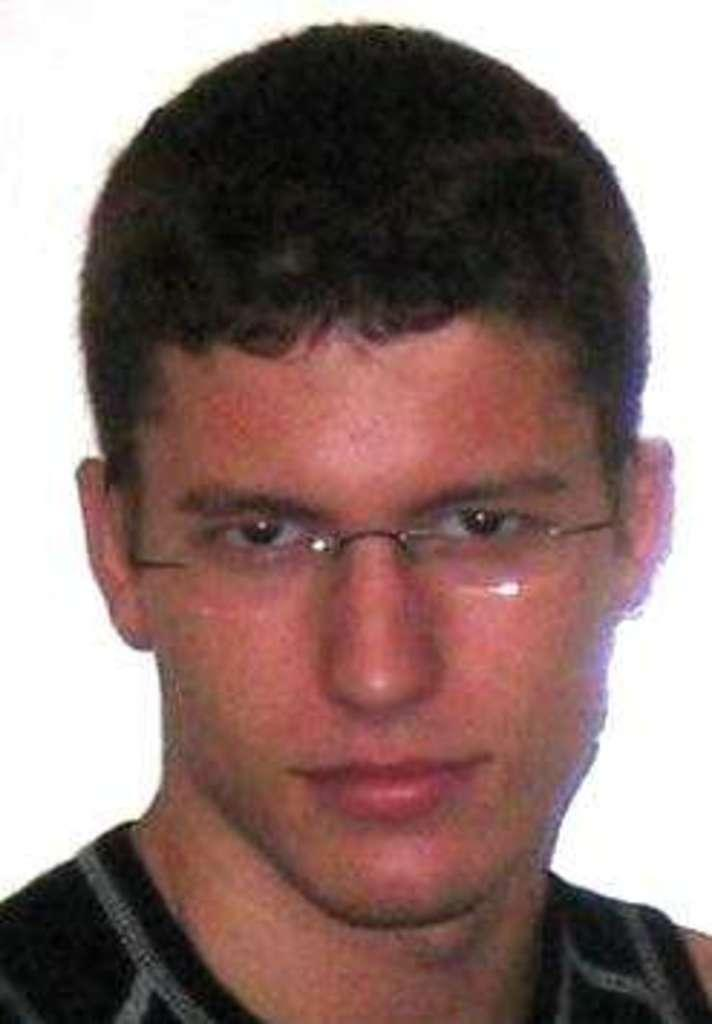What is present in the image? There is a man in the image. Can you describe the man's appearance? The man is wearing spectacles. What is the man wearing in the image? The man is wearing clothes. What is the color of the background in the image? The background of the image is white. What type of surprise can be seen in the image? There is no surprise present in the image. What type of doctor is the man in the image? There is no indication in the image that the man is a doctor. How many rings is the man wearing in the image? There is no mention of rings in the image. 